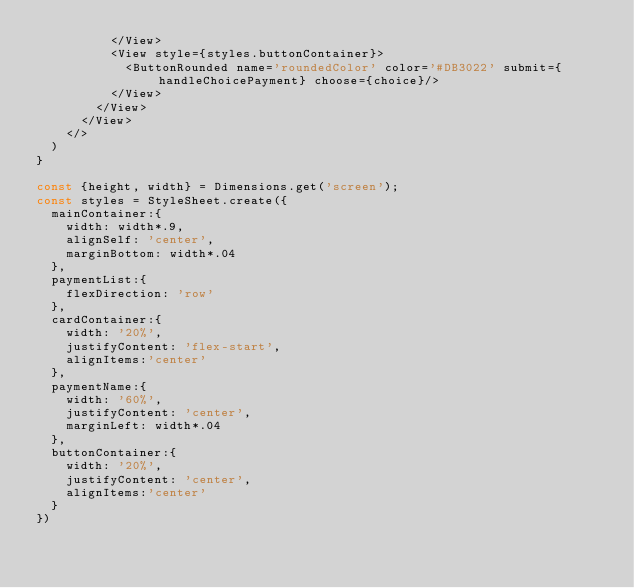Convert code to text. <code><loc_0><loc_0><loc_500><loc_500><_JavaScript_>          </View>
          <View style={styles.buttonContainer}>
            <ButtonRounded name='roundedColor' color='#DB3022' submit={handleChoicePayment} choose={choice}/>
          </View>
        </View>
      </View>
    </>
  )
}

const {height, width} = Dimensions.get('screen');
const styles = StyleSheet.create({
  mainContainer:{
    width: width*.9,
    alignSelf: 'center',
    marginBottom: width*.04
  },
  paymentList:{
    flexDirection: 'row'
  },
  cardContainer:{
    width: '20%',
    justifyContent: 'flex-start',
    alignItems:'center'
  },
  paymentName:{
    width: '60%',
    justifyContent: 'center',
    marginLeft: width*.04
  },
  buttonContainer:{
    width: '20%',
    justifyContent: 'center',
    alignItems:'center'
  }
})</code> 